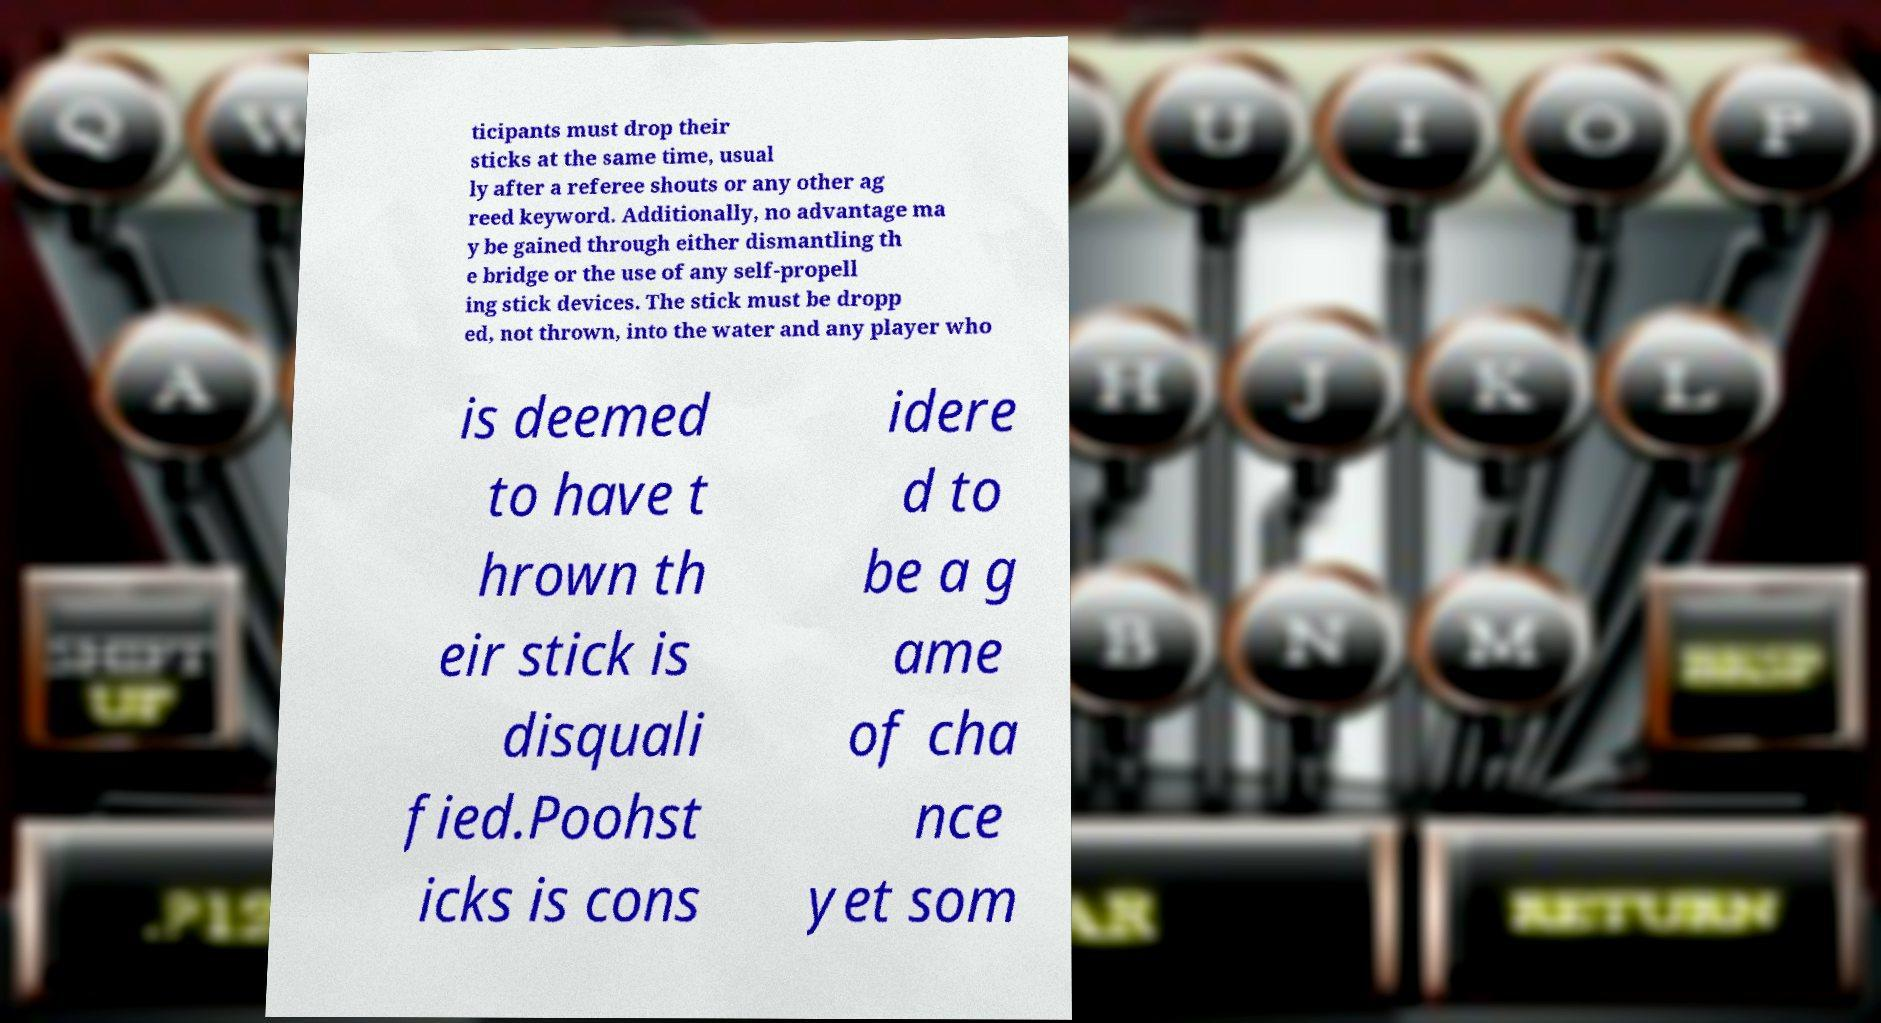Could you extract and type out the text from this image? ticipants must drop their sticks at the same time, usual ly after a referee shouts or any other ag reed keyword. Additionally, no advantage ma y be gained through either dismantling th e bridge or the use of any self-propell ing stick devices. The stick must be dropp ed, not thrown, into the water and any player who is deemed to have t hrown th eir stick is disquali fied.Poohst icks is cons idere d to be a g ame of cha nce yet som 